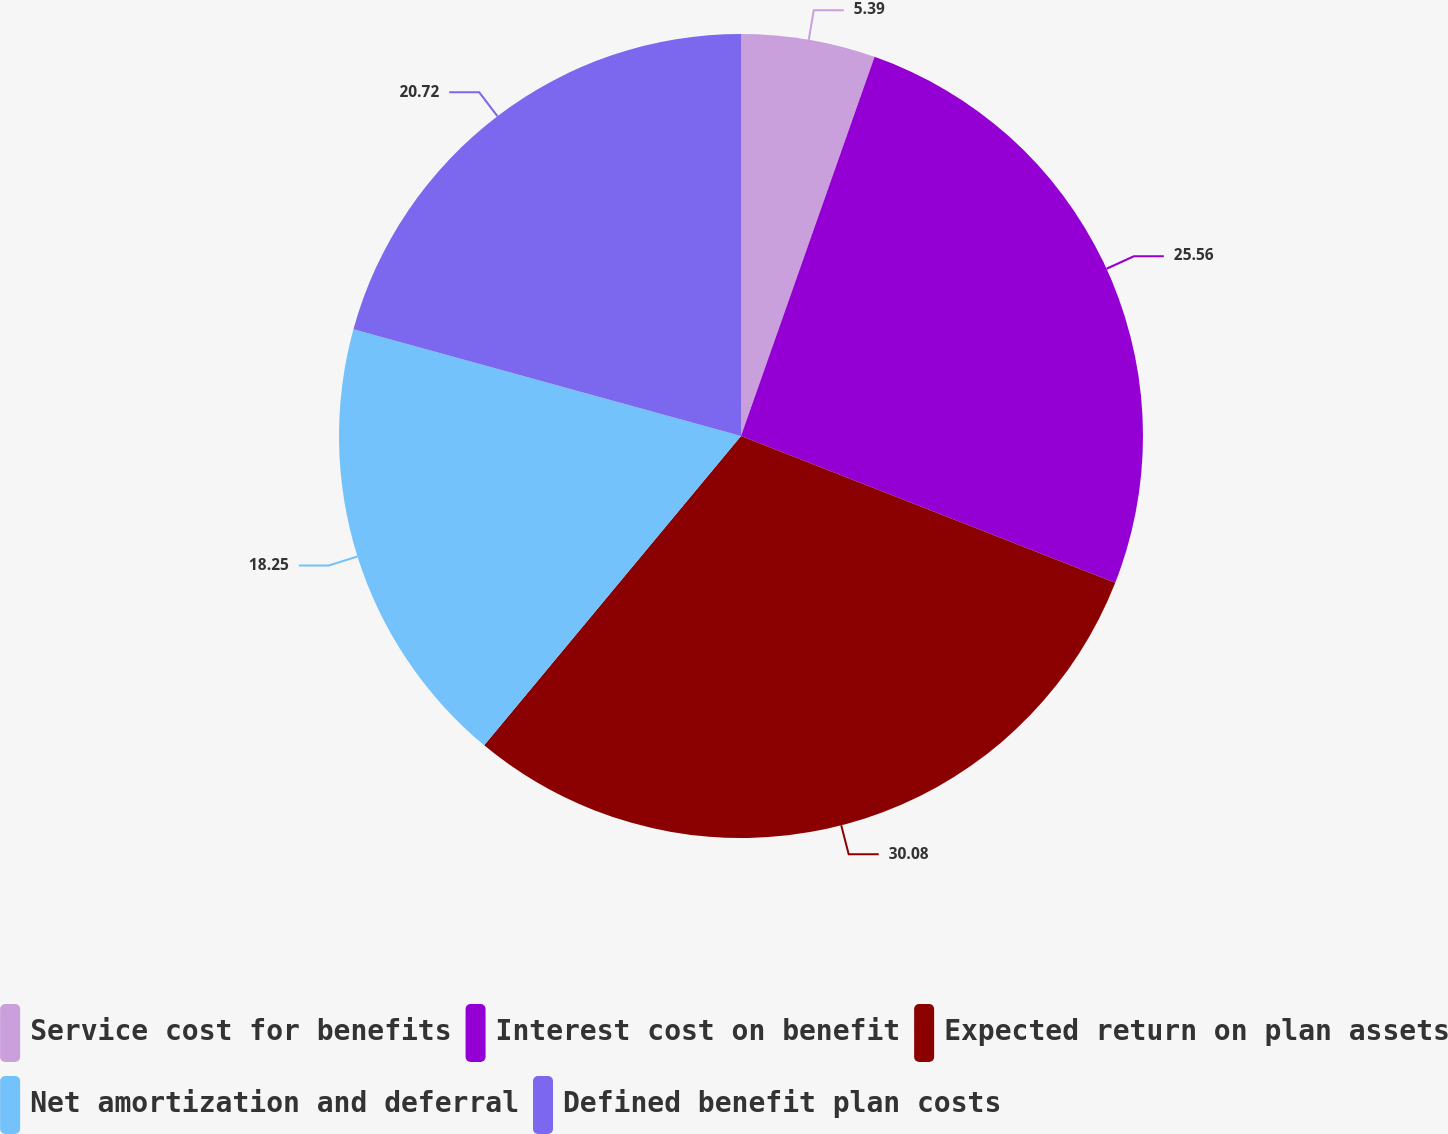Convert chart. <chart><loc_0><loc_0><loc_500><loc_500><pie_chart><fcel>Service cost for benefits<fcel>Interest cost on benefit<fcel>Expected return on plan assets<fcel>Net amortization and deferral<fcel>Defined benefit plan costs<nl><fcel>5.39%<fcel>25.56%<fcel>30.08%<fcel>18.25%<fcel>20.72%<nl></chart> 